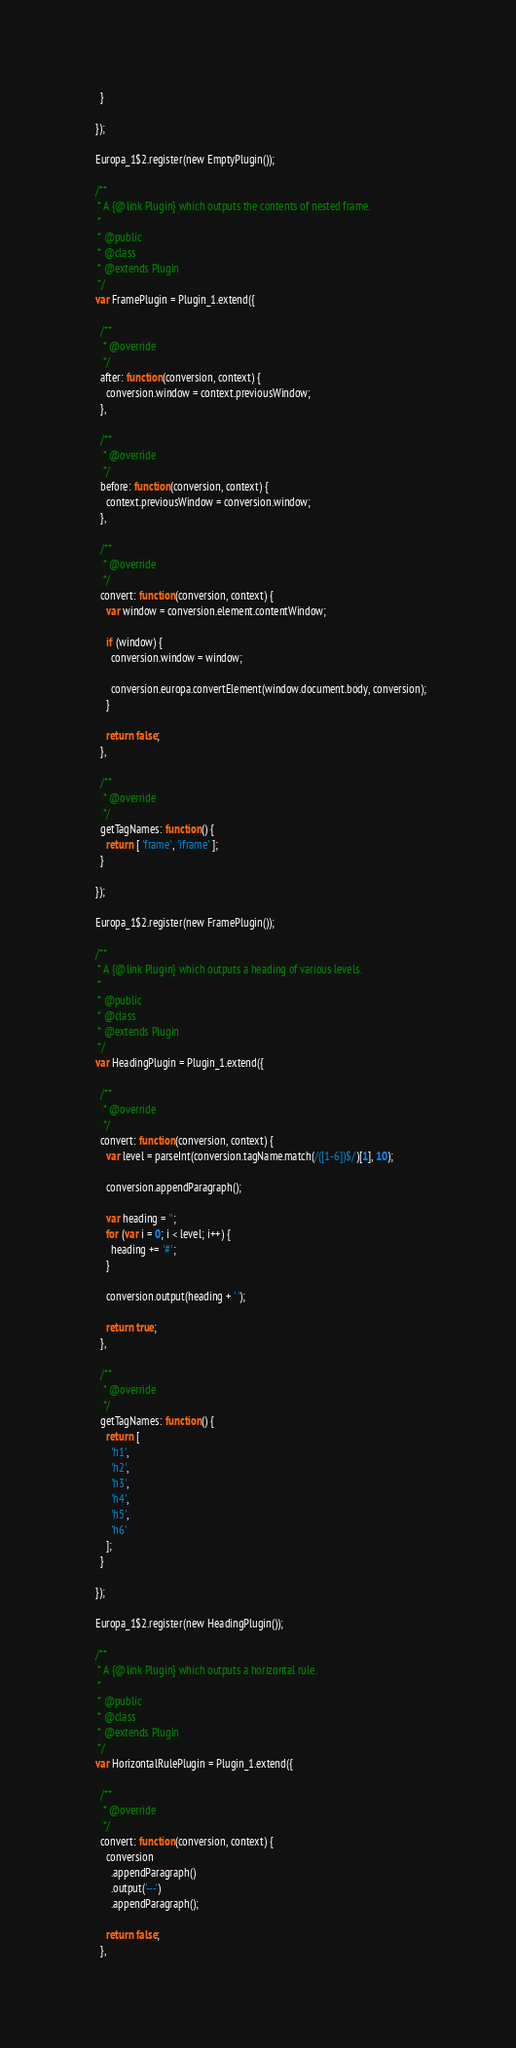<code> <loc_0><loc_0><loc_500><loc_500><_JavaScript_>    }

  });

  Europa_1$2.register(new EmptyPlugin());

  /**
   * A {@link Plugin} which outputs the contents of nested frame.
   *
   * @public
   * @class
   * @extends Plugin
   */
  var FramePlugin = Plugin_1.extend({

    /**
     * @override
     */
    after: function(conversion, context) {
      conversion.window = context.previousWindow;
    },

    /**
     * @override
     */
    before: function(conversion, context) {
      context.previousWindow = conversion.window;
    },

    /**
     * @override
     */
    convert: function(conversion, context) {
      var window = conversion.element.contentWindow;

      if (window) {
        conversion.window = window;

        conversion.europa.convertElement(window.document.body, conversion);
      }

      return false;
    },

    /**
     * @override
     */
    getTagNames: function() {
      return [ 'frame', 'iframe' ];
    }

  });

  Europa_1$2.register(new FramePlugin());

  /**
   * A {@link Plugin} which outputs a heading of various levels.
   *
   * @public
   * @class
   * @extends Plugin
   */
  var HeadingPlugin = Plugin_1.extend({

    /**
     * @override
     */
    convert: function(conversion, context) {
      var level = parseInt(conversion.tagName.match(/([1-6])$/)[1], 10);

      conversion.appendParagraph();

      var heading = '';
      for (var i = 0; i < level; i++) {
        heading += '#';
      }

      conversion.output(heading + ' ');

      return true;
    },

    /**
     * @override
     */
    getTagNames: function() {
      return [
        'h1',
        'h2',
        'h3',
        'h4',
        'h5',
        'h6'
      ];
    }

  });

  Europa_1$2.register(new HeadingPlugin());

  /**
   * A {@link Plugin} which outputs a horizontal rule.
   *
   * @public
   * @class
   * @extends Plugin
   */
  var HorizontalRulePlugin = Plugin_1.extend({

    /**
     * @override
     */
    convert: function(conversion, context) {
      conversion
        .appendParagraph()
        .output('---')
        .appendParagraph();

      return false;
    },
</code> 